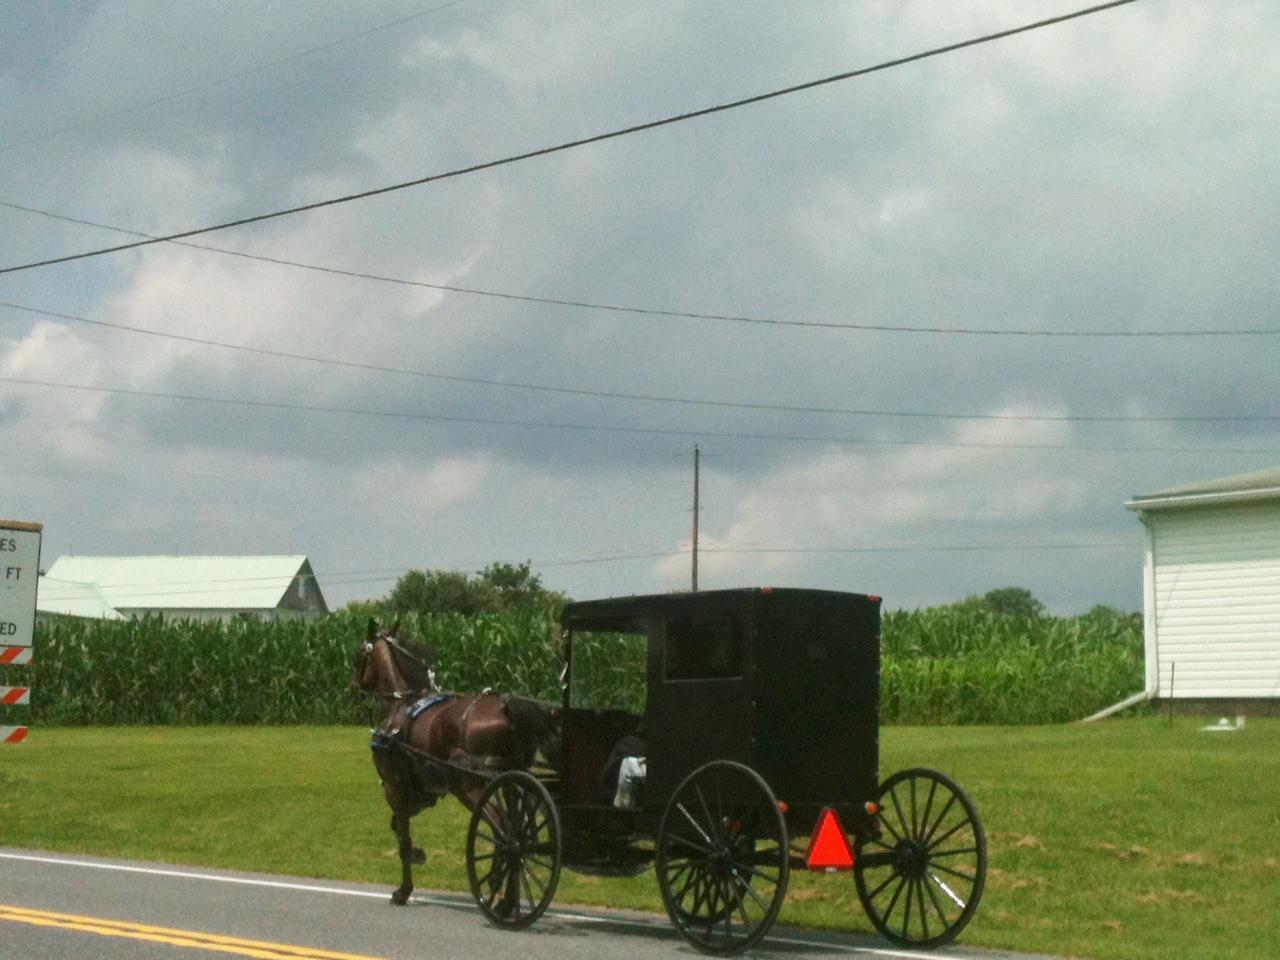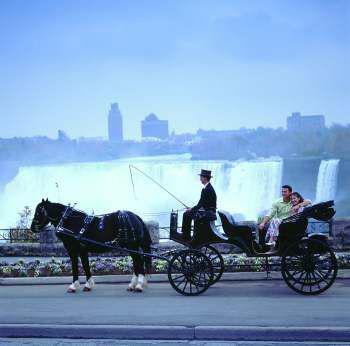The first image is the image on the left, the second image is the image on the right. For the images shown, is this caption "There are three or more horses in at least one image." true? Answer yes or no. No. 